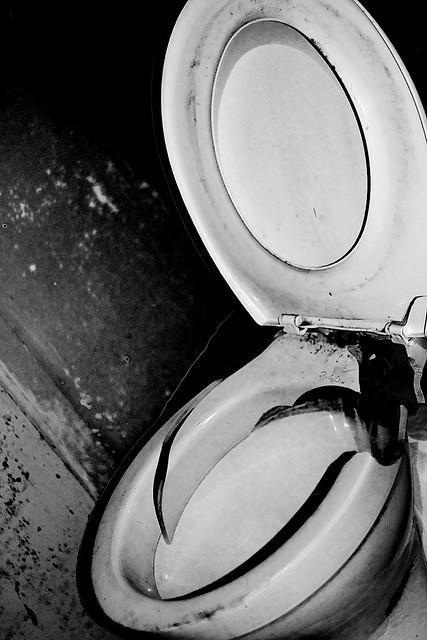How many men are holding a racket?
Give a very brief answer. 0. 